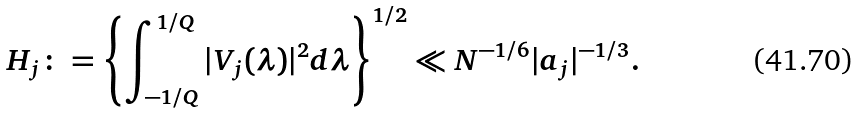Convert formula to latex. <formula><loc_0><loc_0><loc_500><loc_500>H _ { j } \colon = \left \{ \int _ { - 1 / Q } ^ { 1 / Q } | V _ { j } ( \lambda ) | ^ { 2 } d \lambda \right \} ^ { 1 / 2 } \ll N ^ { - 1 / 6 } | a _ { j } | ^ { - 1 / 3 } .</formula> 